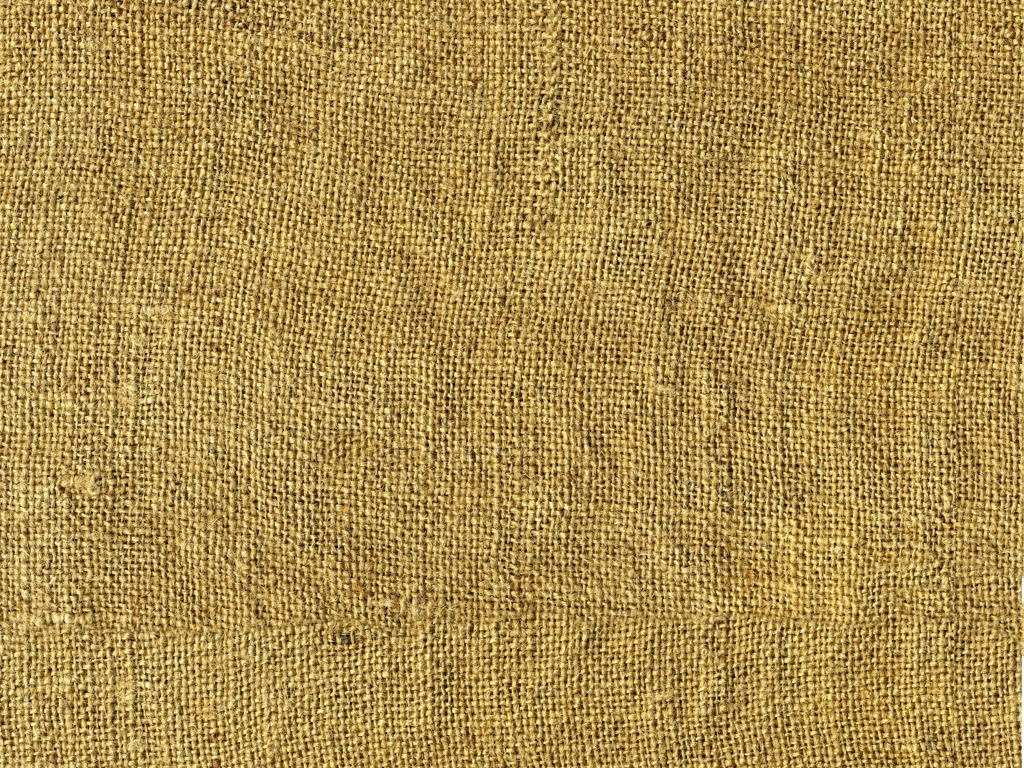Does the image have any quality issues related to color? Upon inspection, the image does not exhibit any quality issues pertaining to color. The hues seem consistent and appropriate for the texture depicted, without notable color distortion or imbalance. 